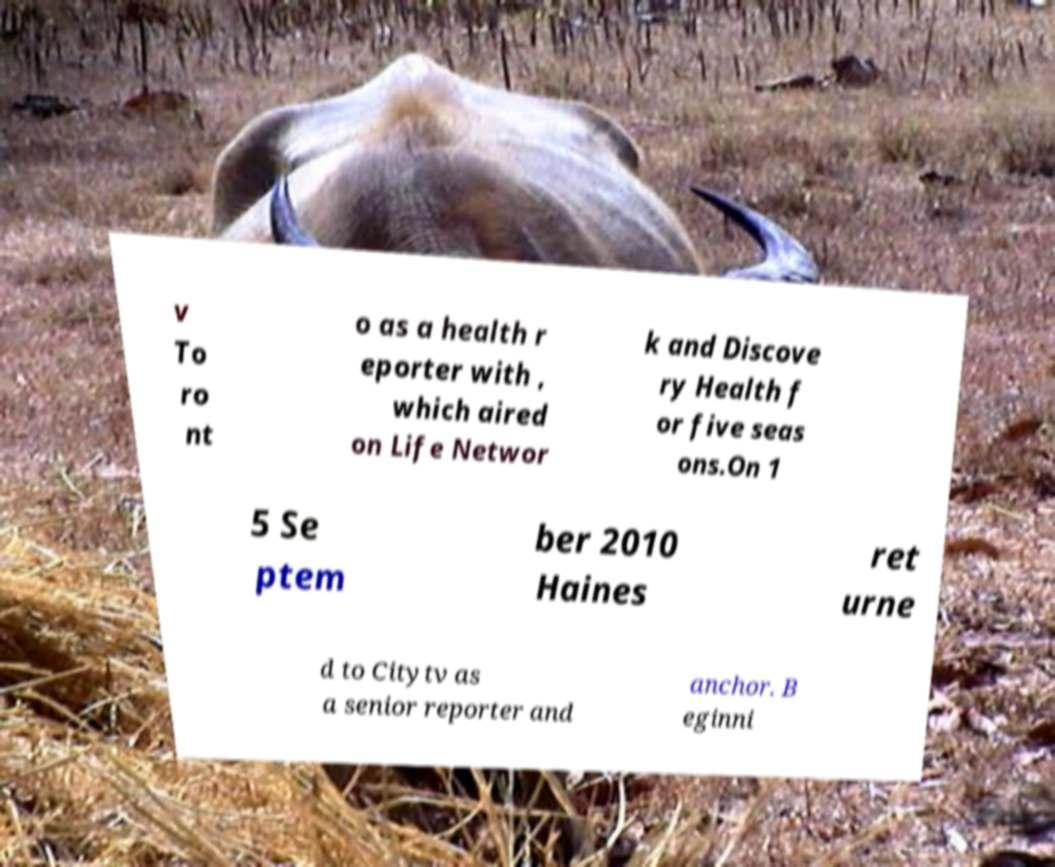Could you assist in decoding the text presented in this image and type it out clearly? v To ro nt o as a health r eporter with , which aired on Life Networ k and Discove ry Health f or five seas ons.On 1 5 Se ptem ber 2010 Haines ret urne d to Citytv as a senior reporter and anchor. B eginni 